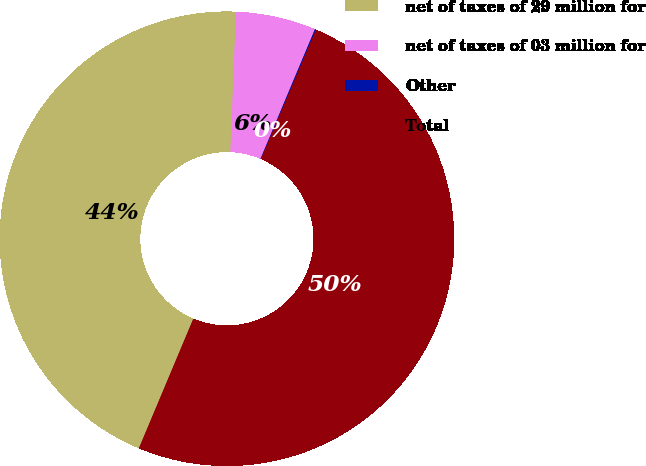Convert chart. <chart><loc_0><loc_0><loc_500><loc_500><pie_chart><fcel>net of taxes of 29 million for<fcel>net of taxes of 03 million for<fcel>Other<fcel>Total<nl><fcel>44.31%<fcel>5.69%<fcel>0.08%<fcel>49.92%<nl></chart> 